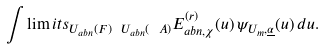<formula> <loc_0><loc_0><loc_500><loc_500>\int \lim i t s _ { U _ { a b n } ( F ) \ U _ { a b n } ( { \ A } ) } E _ { a b n , \chi } ^ { ( r ) } ( u ) \, \psi _ { U _ { m } , \underline { \alpha } } ( u ) \, d u .</formula> 